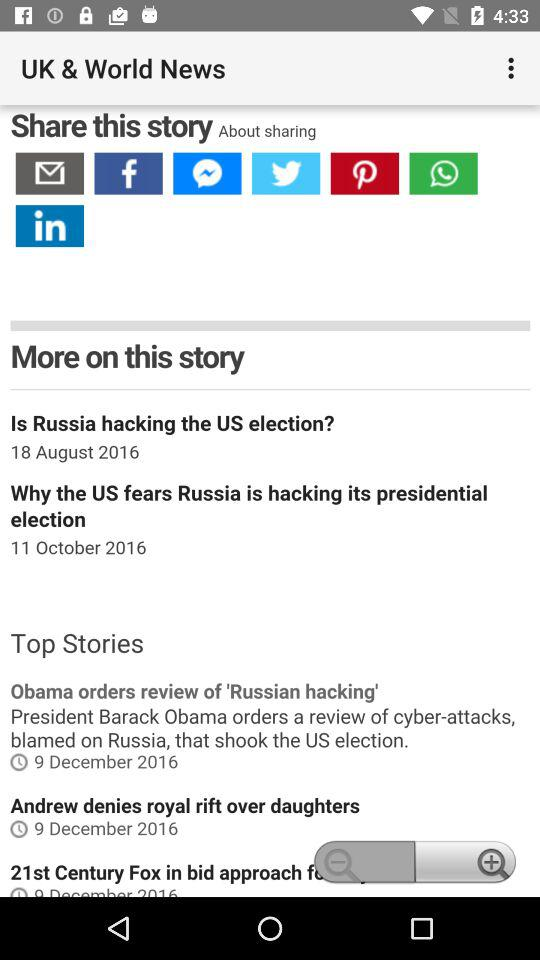On which date was the news "Why the US fears Russia is hacking its presidential election" posted? The date is October 11, 2016. 